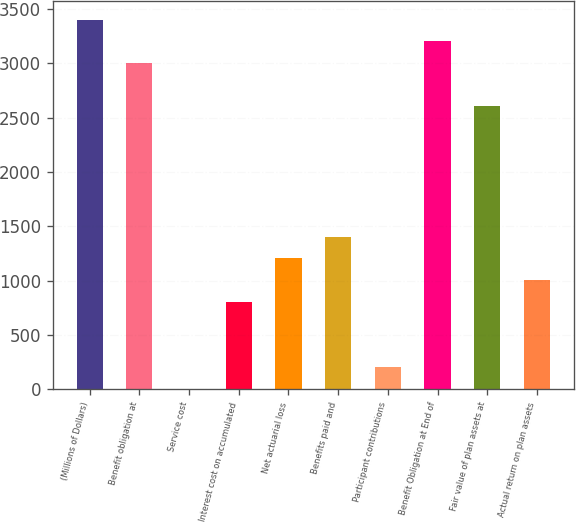Convert chart to OTSL. <chart><loc_0><loc_0><loc_500><loc_500><bar_chart><fcel>(Millions of Dollars)<fcel>Benefit obligation at<fcel>Service cost<fcel>Interest cost on accumulated<fcel>Net actuarial loss<fcel>Benefits paid and<fcel>Participant contributions<fcel>Benefit Obligation at End of<fcel>Fair value of plan assets at<fcel>Actual return on plan assets<nl><fcel>3401.2<fcel>3002<fcel>8<fcel>806.4<fcel>1205.6<fcel>1405.2<fcel>207.6<fcel>3201.6<fcel>2602.8<fcel>1006<nl></chart> 